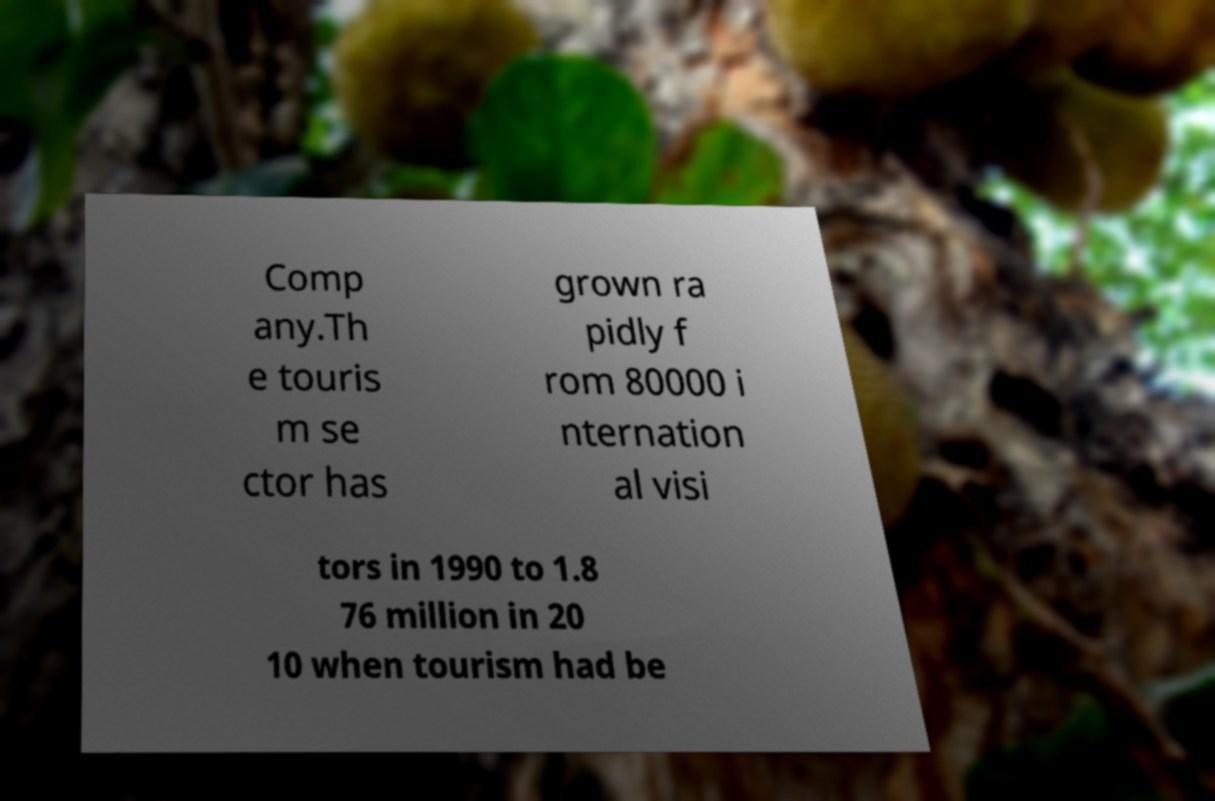I need the written content from this picture converted into text. Can you do that? Comp any.Th e touris m se ctor has grown ra pidly f rom 80000 i nternation al visi tors in 1990 to 1.8 76 million in 20 10 when tourism had be 